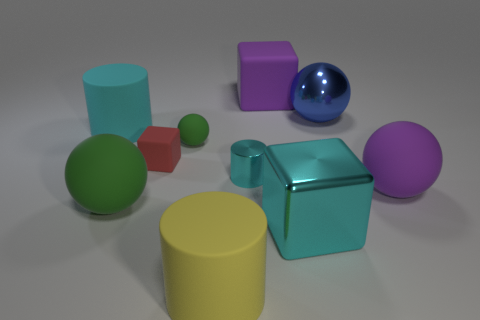There is a big yellow thing in front of the tiny block; what shape is it?
Provide a short and direct response. Cylinder. Are there any purple things that are in front of the cylinder that is behind the small matte block?
Give a very brief answer. Yes. There is a big rubber object that is on the left side of the yellow object and behind the small metal cylinder; what is its color?
Your answer should be compact. Cyan. There is a cylinder left of the rubber cylinder in front of the tiny green rubber thing; is there a large cylinder that is to the right of it?
Give a very brief answer. Yes. There is another yellow object that is the same shape as the tiny metallic object; what is its size?
Your answer should be very brief. Large. Are there any small blue objects?
Keep it short and to the point. No. Is the color of the big shiny cube the same as the big matte thing that is behind the shiny sphere?
Your answer should be very brief. No. How big is the cyan thing that is in front of the big ball left of the big cyan object on the right side of the metallic cylinder?
Ensure brevity in your answer.  Large. What number of metal blocks are the same color as the tiny metallic thing?
Your answer should be very brief. 1. What number of things are large green rubber things or big rubber balls that are left of the large shiny sphere?
Offer a terse response. 1. 